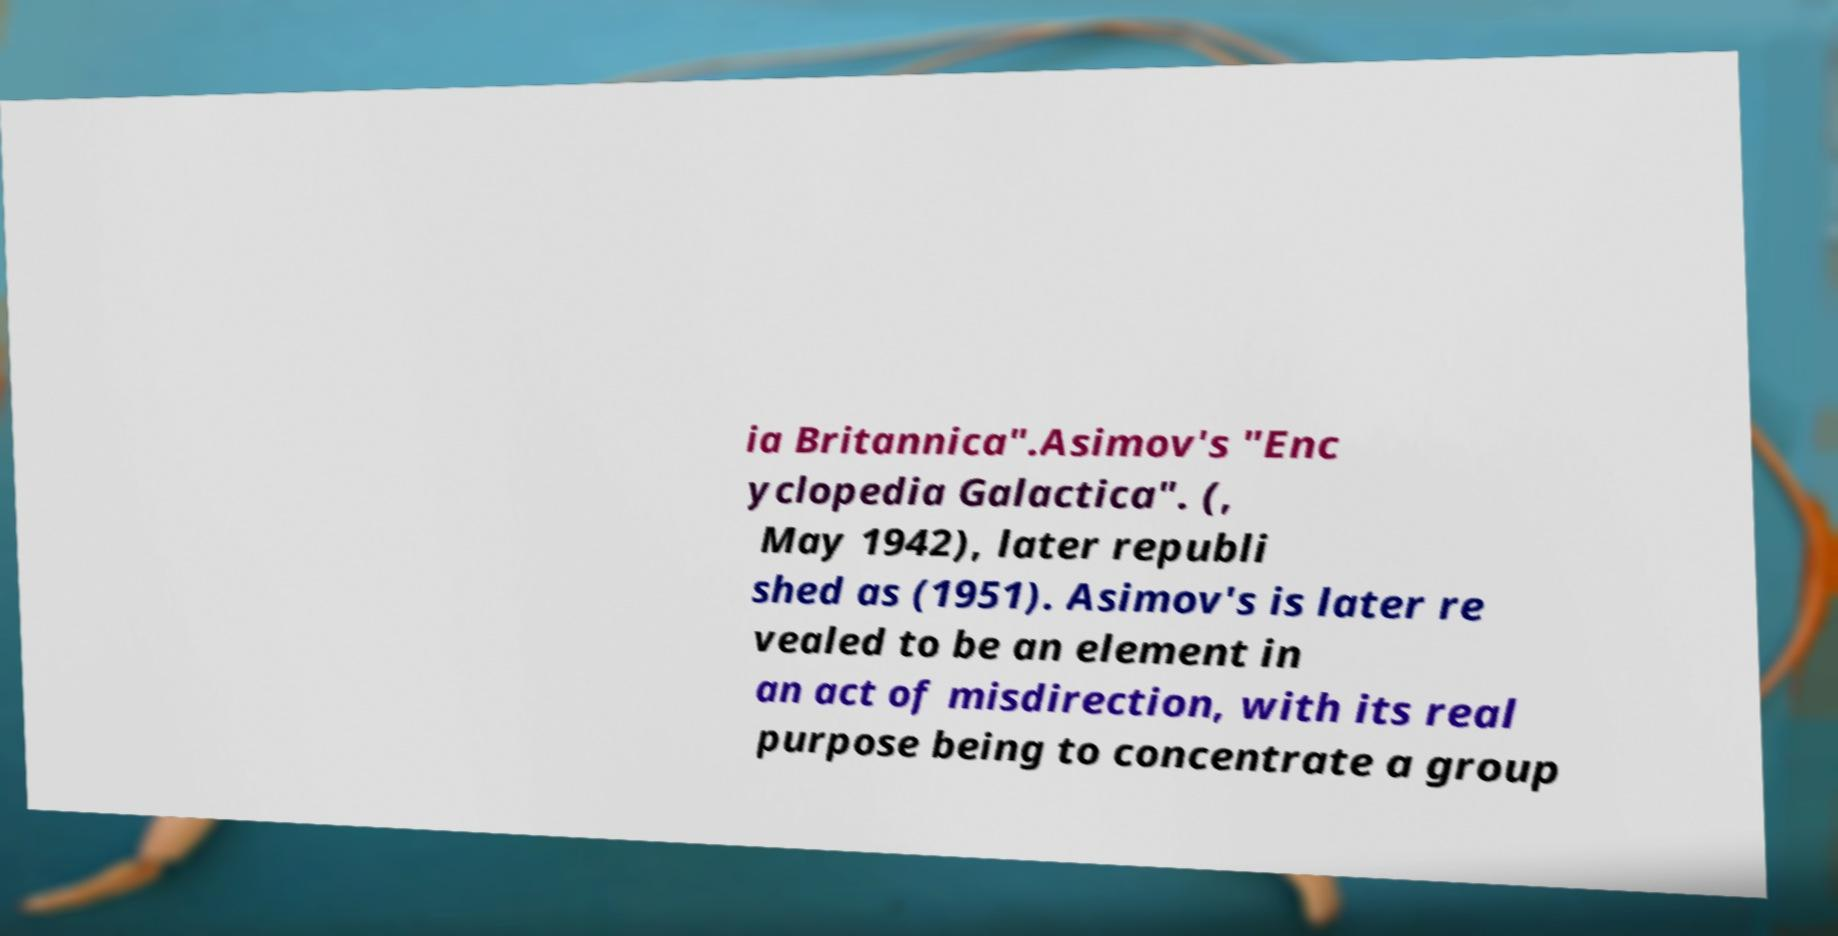Can you accurately transcribe the text from the provided image for me? ia Britannica".Asimov's "Enc yclopedia Galactica". (, May 1942), later republi shed as (1951). Asimov's is later re vealed to be an element in an act of misdirection, with its real purpose being to concentrate a group 